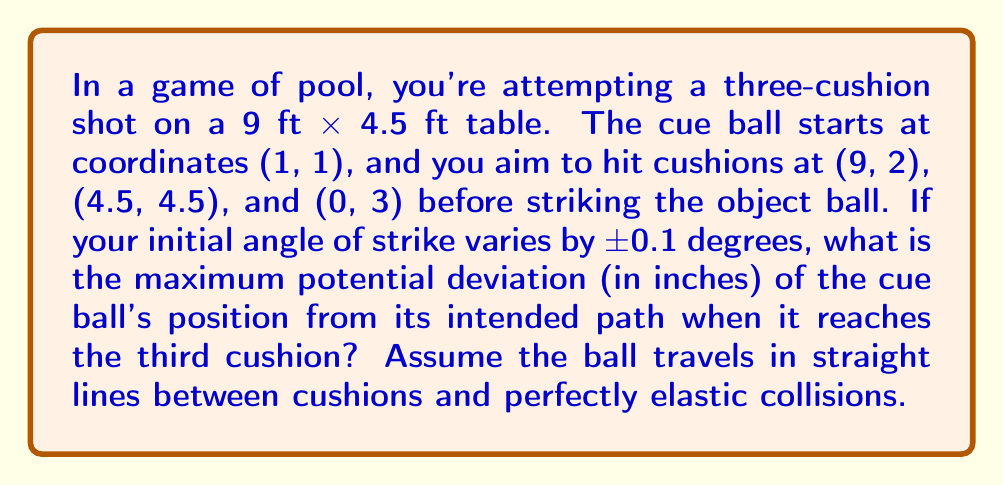Show me your answer to this math problem. Let's approach this step-by-step:

1) First, we need to calculate the intended path length (L) from the starting point to the third cushion:

   $$L = \sqrt{(9-1)^2 + (2-1)^2} + \sqrt{(4.5-9)^2 + (4.5-2)^2} + \sqrt{(0-4.5)^2 + (3-4.5)^2}$$
   $$L \approx 8.06 + 5.59 + 4.61 = 18.26 \text{ ft}$$

2) Now, we need to consider the effect of a 0.1 degree angle deviation. The deviation angle in radians is:

   $$\theta = 0.1 \times \frac{\pi}{180} \approx 0.001745 \text{ radians}$$

3) For small angles, the deviation (D) can be approximated as:

   $$D = L \times \tan(\theta) \approx L \times \theta$$

4) Substituting our values:

   $$D \approx 18.26 \text{ ft} \times 0.001745 = 0.0319 \text{ ft}$$

5) Converting to inches:

   $$D \approx 0.0319 \text{ ft} \times 12 \text{ in/ft} = 0.383 \text{ inches}$$

6) This is the deviation for a +0.1 degree change. For a -0.1 degree change, the deviation would be in the opposite direction but of the same magnitude. Therefore, the maximum potential deviation is twice this value:

   $$D_{\text{max}} = 2 \times 0.383 = 0.766 \text{ inches}$$

This demonstrates the sensitivity to initial conditions in a multi-cushion shot, where a tiny change in the initial angle can lead to a significant deviation over the course of the shot.
Answer: 0.766 inches 